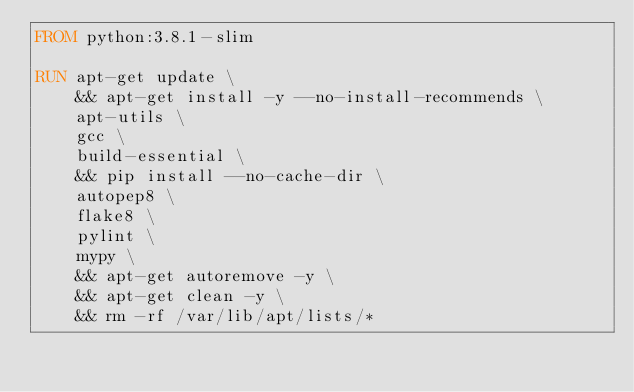<code> <loc_0><loc_0><loc_500><loc_500><_Dockerfile_>FROM python:3.8.1-slim

RUN apt-get update \
    && apt-get install -y --no-install-recommends \
    apt-utils \
    gcc \
    build-essential \
    && pip install --no-cache-dir \
    autopep8 \
    flake8 \
    pylint \
    mypy \
    && apt-get autoremove -y \
    && apt-get clean -y \
    && rm -rf /var/lib/apt/lists/*
</code> 